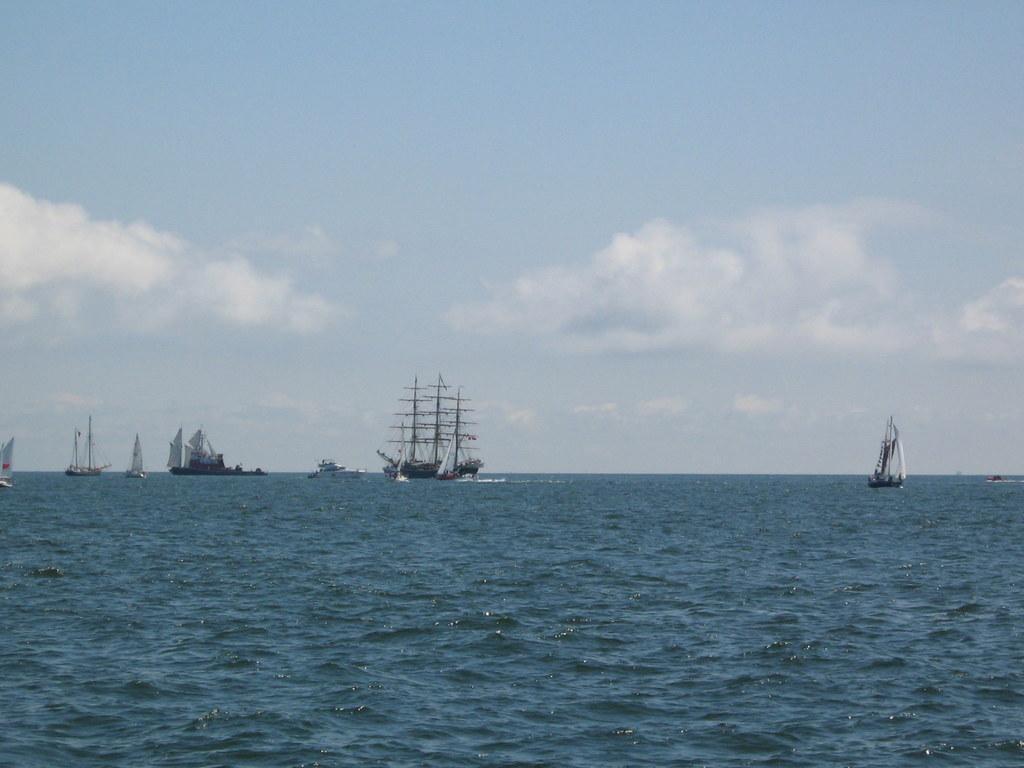Could you give a brief overview of what you see in this image? In this picture I can see there is an ocean, there are few ships sailing on the ocean. The sky is clear. 